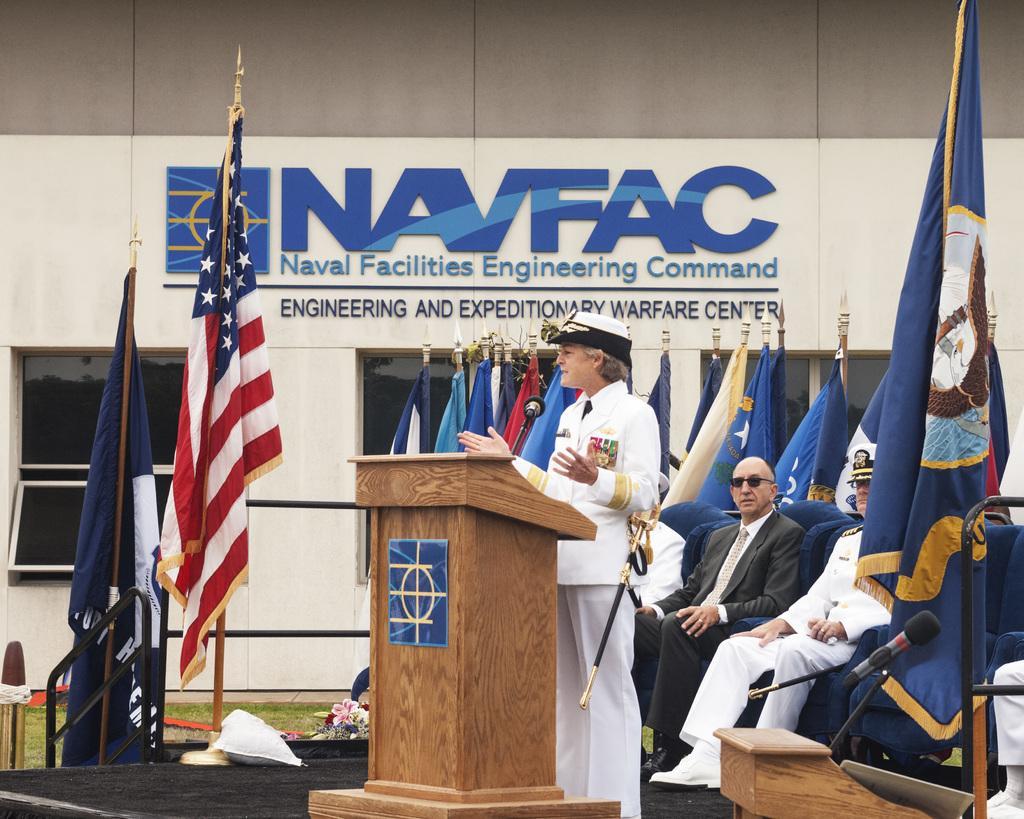How would you summarize this image in a sentence or two? In the center of the image we can see a person is standing in-front of the podium and talking and wearing a uniform, cap. On the podium, we can see a mic. In the background of the image we can see a building, text on the wall, flags, rods and some people are sitting on the chairs. At the bottom of the image we can see the stage, podium, mic, paper, ground, flower pot. 